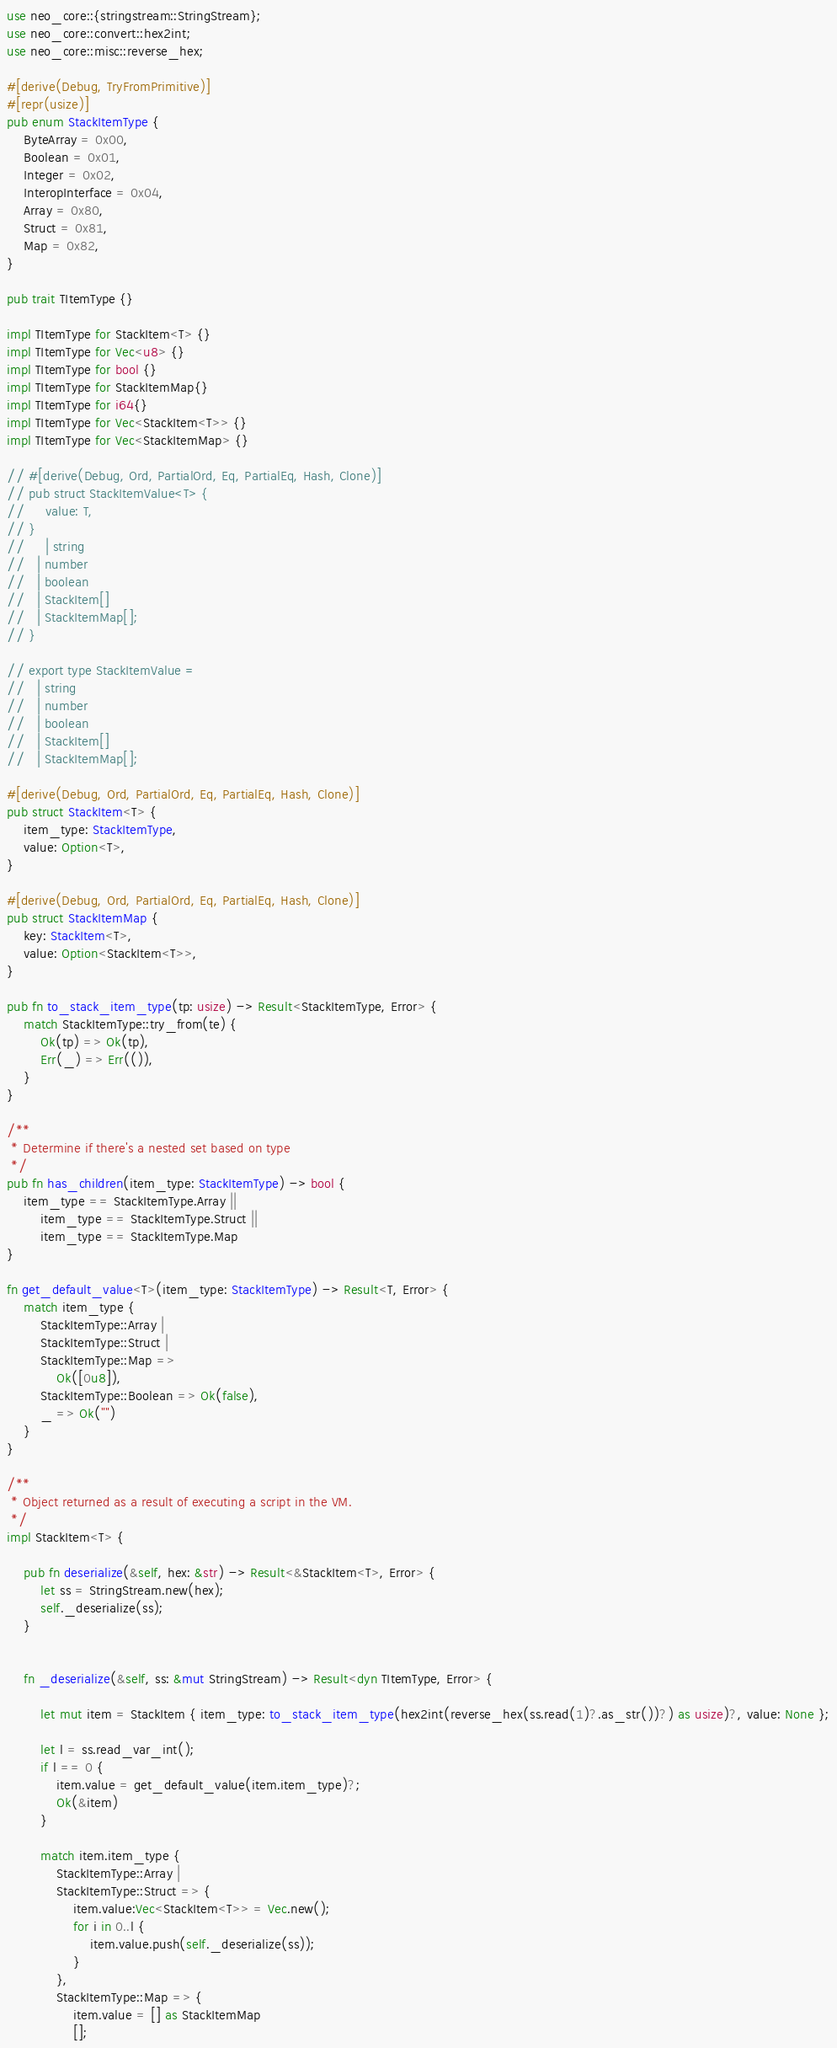<code> <loc_0><loc_0><loc_500><loc_500><_Rust_>use neo_core::{stringstream::StringStream};
use neo_core::convert::hex2int;
use neo_core::misc::reverse_hex;

#[derive(Debug, TryFromPrimitive)]
#[repr(usize)]
pub enum StackItemType {
    ByteArray = 0x00,
    Boolean = 0x01,
    Integer = 0x02,
    InteropInterface = 0x04,
    Array = 0x80,
    Struct = 0x81,
    Map = 0x82,
}

pub trait TItemType {}

impl TItemType for StackItem<T> {}
impl TItemType for Vec<u8> {}
impl TItemType for bool {}
impl TItemType for StackItemMap{}
impl TItemType for i64{}
impl TItemType for Vec<StackItem<T>> {}
impl TItemType for Vec<StackItemMap> {}

// #[derive(Debug, Ord, PartialOrd, Eq, PartialEq, Hash, Clone)]
// pub struct StackItemValue<T> {
//     value: T,
// }
//     | string
//   | number
//   | boolean
//   | StackItem[]
//   | StackItemMap[];
// }

// export type StackItemValue =
//   | string
//   | number
//   | boolean
//   | StackItem[]
//   | StackItemMap[];

#[derive(Debug, Ord, PartialOrd, Eq, PartialEq, Hash, Clone)]
pub struct StackItem<T> {
    item_type: StackItemType,
    value: Option<T>,
}

#[derive(Debug, Ord, PartialOrd, Eq, PartialEq, Hash, Clone)]
pub struct StackItemMap {
    key: StackItem<T>,
    value: Option<StackItem<T>>,
}

pub fn to_stack_item_type(tp: usize) -> Result<StackItemType, Error> {
    match StackItemType::try_from(te) {
        Ok(tp) => Ok(tp),
        Err(_) => Err(()),
    }
}

/**
 * Determine if there's a nested set based on type
 */
pub fn has_children(item_type: StackItemType) -> bool {
    item_type == StackItemType.Array ||
        item_type == StackItemType.Struct ||
        item_type == StackItemType.Map
}

fn get_default_value<T>(item_type: StackItemType) -> Result<T, Error> {
    match item_type {
        StackItemType::Array |
        StackItemType::Struct |
        StackItemType::Map =>
            Ok([0u8]),
        StackItemType::Boolean => Ok(false),
        _ => Ok("")
    }
}

/**
 * Object returned as a result of executing a script in the VM.
 */
impl StackItem<T> {

    pub fn deserialize(&self, hex: &str) -> Result<&StackItem<T>, Error> {
        let ss = StringStream.new(hex);
        self._deserialize(ss);
    }


    fn _deserialize(&self, ss: &mut StringStream) -> Result<dyn TItemType, Error> {

        let mut item = StackItem { item_type: to_stack_item_type(hex2int(reverse_hex(ss.read(1)?.as_str())?) as usize)?, value: None };

        let l = ss.read_var_int();
        if l == 0 {
            item.value = get_default_value(item.item_type)?;
            Ok(&item)
        }

        match item.item_type {
            StackItemType::Array |
            StackItemType::Struct => {
                item.value:Vec<StackItem<T>> = Vec.new();
                for i in 0..l {
                    item.value.push(self._deserialize(ss));
                }
            },
            StackItemType::Map => {
                item.value = [] as StackItemMap
                [];</code> 